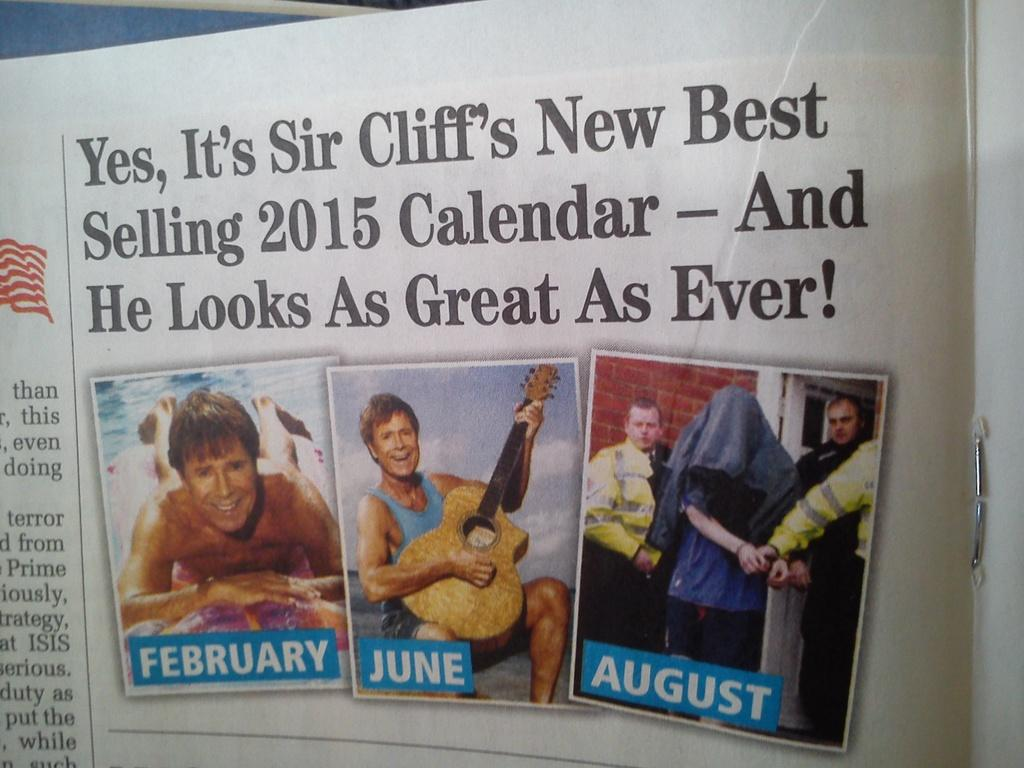What is the main object in the image? There is a book in the image. What is depicted on the book's cover? The book has a picture of a man playing guitar. What is the man's expression in the image? The man is smiling. How many people are present in the image? There are four persons standing in the image. What can be seen in the background of the image? There is a wall in the background of the image. Can you tell me how many friends are sitting on the drawer in the image? There is no drawer or friends present in the image. What color is the sock on the man's foot in the image? There is no sock or man's foot visible in the image, as it only features a book with a picture of a man playing guitar. 